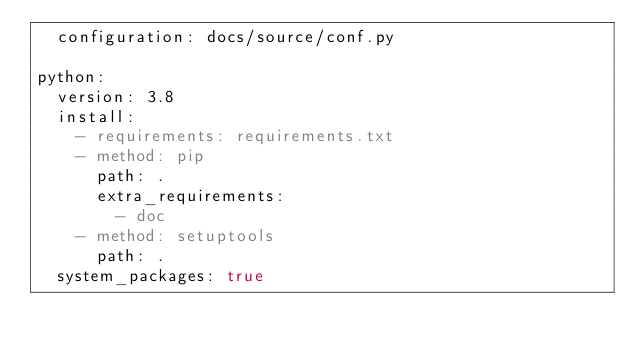<code> <loc_0><loc_0><loc_500><loc_500><_YAML_>  configuration: docs/source/conf.py

python:
  version: 3.8
  install:
    - requirements: requirements.txt
    - method: pip
      path: .
      extra_requirements:
        - doc
    - method: setuptools
      path: .
  system_packages: true
</code> 